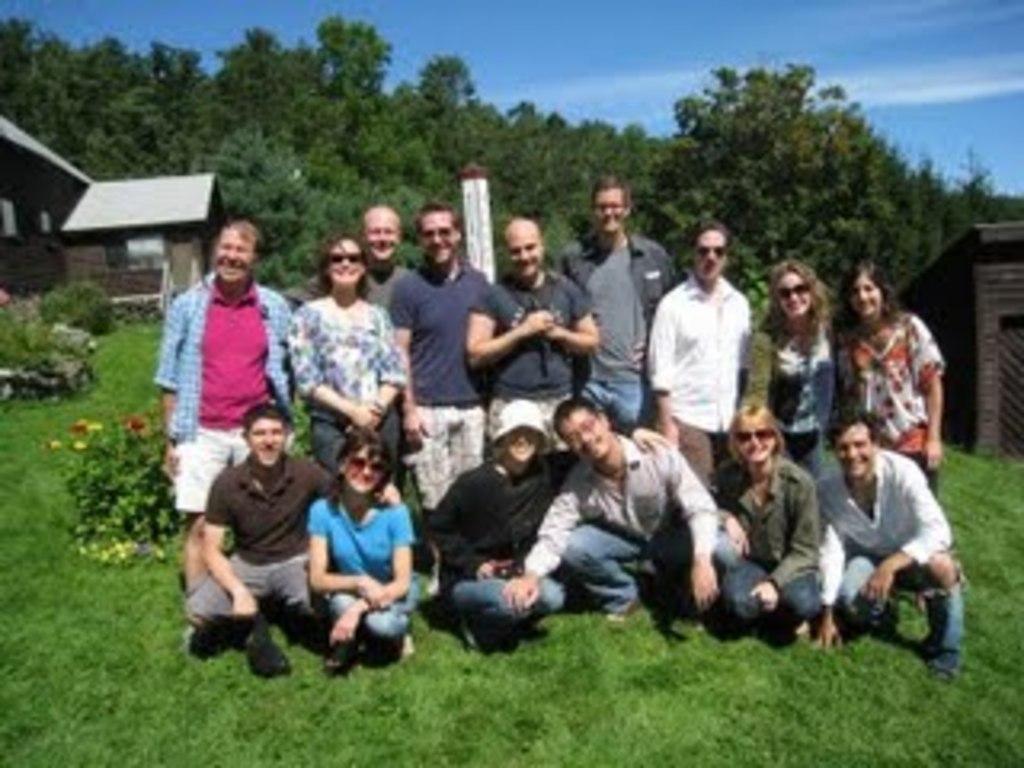Describe this image in one or two sentences. In this image I can see a group of people on grass, flowering plants, pole, houses, trees and the sky. This image is taken may be during a day. 